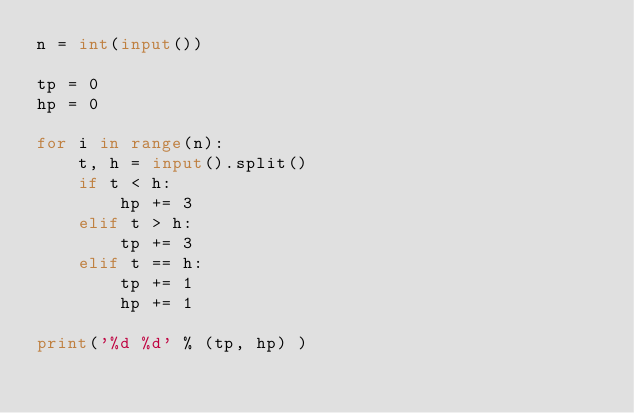Convert code to text. <code><loc_0><loc_0><loc_500><loc_500><_Python_>n = int(input())

tp = 0
hp = 0

for i in range(n):
    t, h = input().split()
    if t < h:
        hp += 3
    elif t > h:
        tp += 3
    elif t == h:
        tp += 1
        hp += 1

print('%d %d' % (tp, hp) )</code> 